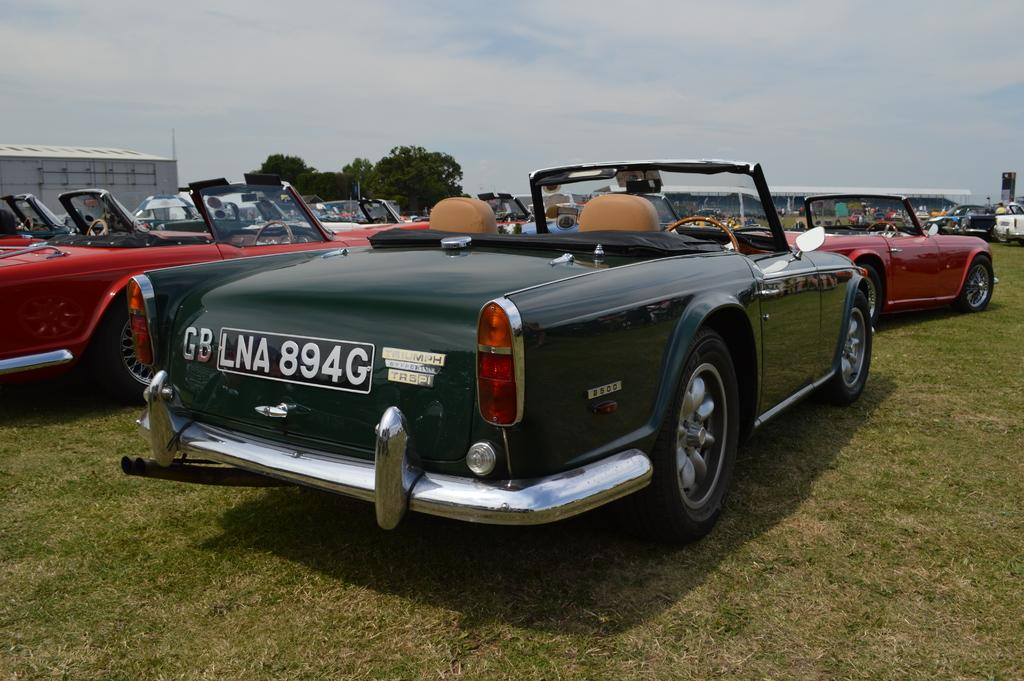What can be seen in the background of the image? There is a sky in the image. What type of vegetation is present in the image? There are trees in the image. What type of vehicles can be seen in the image? There are cars in the image. What type of ground surface is visible in the image? There is grass in the image. Where is the building located in the image? There is a building towards the left side of the image. Can you tell me how many experts are holding a pail in the image? There are no experts or pails present in the image. What type of arm is visible in the image? There are no arms visible in the image. 